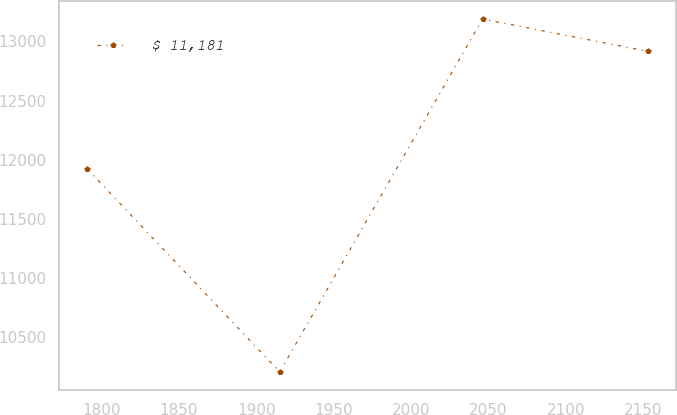Convert chart. <chart><loc_0><loc_0><loc_500><loc_500><line_chart><ecel><fcel>$ 11,181<nl><fcel>1791.04<fcel>11921.7<nl><fcel>1915.21<fcel>10208.2<nl><fcel>2046.09<fcel>13188.3<nl><fcel>2152.9<fcel>12915.1<nl></chart> 